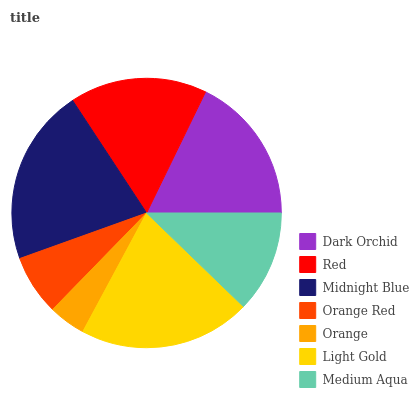Is Orange the minimum?
Answer yes or no. Yes. Is Midnight Blue the maximum?
Answer yes or no. Yes. Is Red the minimum?
Answer yes or no. No. Is Red the maximum?
Answer yes or no. No. Is Dark Orchid greater than Red?
Answer yes or no. Yes. Is Red less than Dark Orchid?
Answer yes or no. Yes. Is Red greater than Dark Orchid?
Answer yes or no. No. Is Dark Orchid less than Red?
Answer yes or no. No. Is Red the high median?
Answer yes or no. Yes. Is Red the low median?
Answer yes or no. Yes. Is Orange the high median?
Answer yes or no. No. Is Midnight Blue the low median?
Answer yes or no. No. 